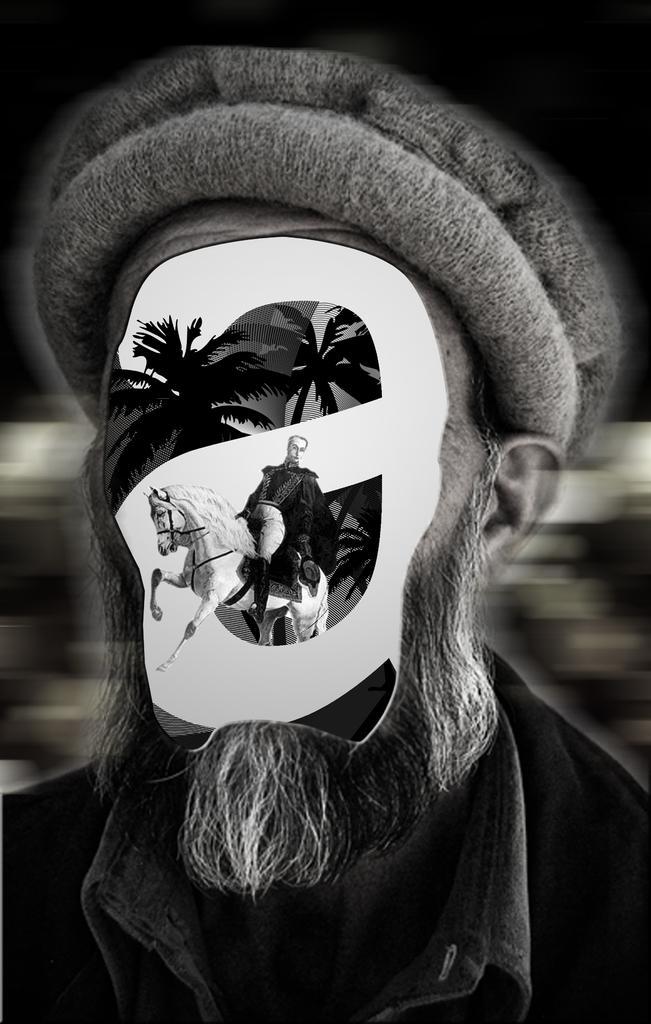How would you summarize this image in a sentence or two? This is a black and white graphic image of a person with a building,tree and a horse on his face. 